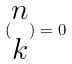Convert formula to latex. <formula><loc_0><loc_0><loc_500><loc_500>( \begin{matrix} n \\ k \end{matrix} ) = 0</formula> 